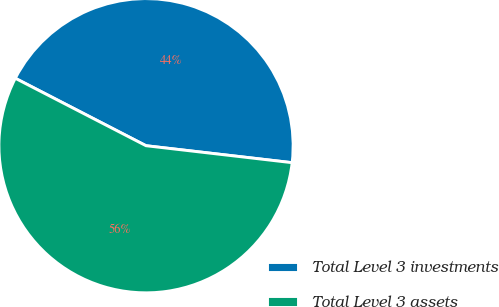<chart> <loc_0><loc_0><loc_500><loc_500><pie_chart><fcel>Total Level 3 investments<fcel>Total Level 3 assets<nl><fcel>44.26%<fcel>55.74%<nl></chart> 